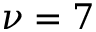<formula> <loc_0><loc_0><loc_500><loc_500>\nu = 7</formula> 